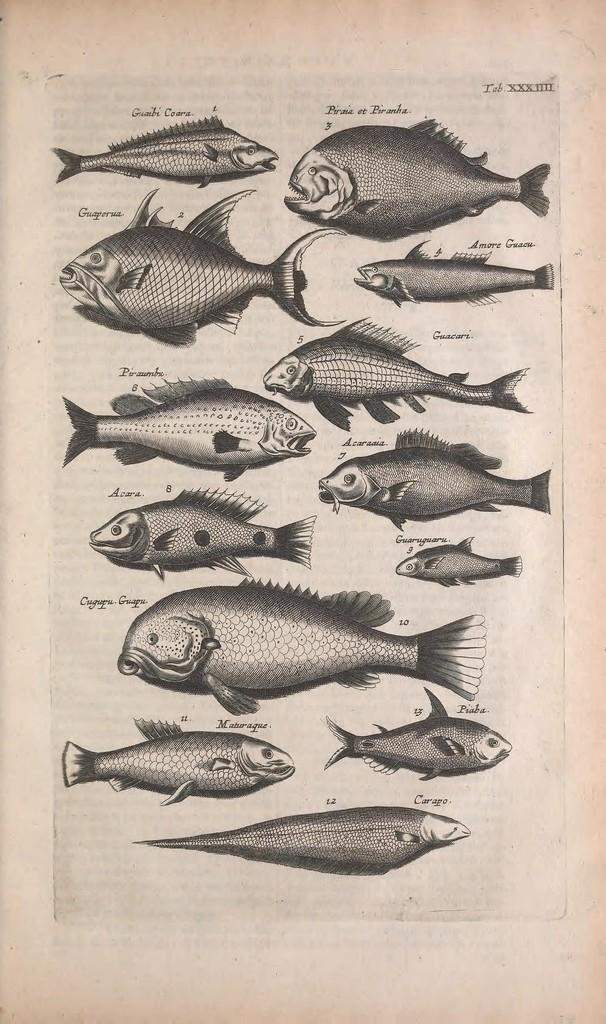What is present in the image that contains information or illustrations? There is a paper in the image. What type of images can be seen on the paper? The paper contains images of fish. Is there any text on the paper? Yes, there is text on the paper. What type of plant can be seen interacting with the fish on the paper? There is no plant present on the paper, and the images of fish are not interacting with any living organisms. 